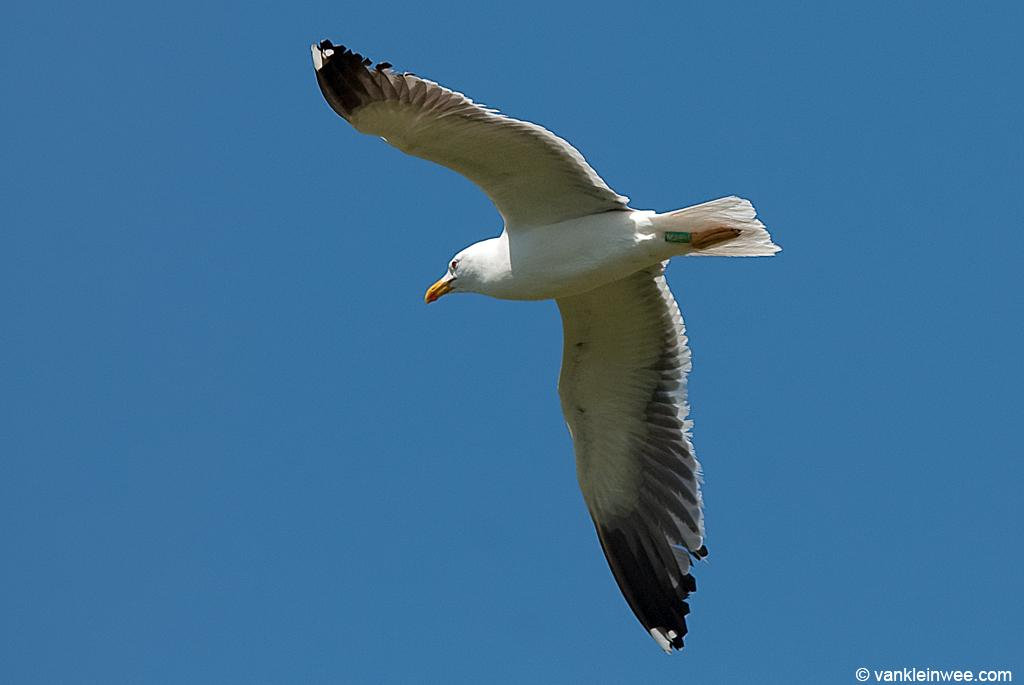What type of animal is in the image? There is a white color bird in the image. What is the bird doing in the image? The bird is flying in the air. What can be seen in the background of the image? The sky is visible in the background of the image. Is there any additional information or marking on the image? Yes, there is a watermark on the bottom right of the image. What type of egg is the bird sitting on in the image? There is no egg present in the image; the bird is flying in the air. What experience does the bird have with flying in the image? The image does not provide information about the bird's experience with flying, only that it is flying in the air. 